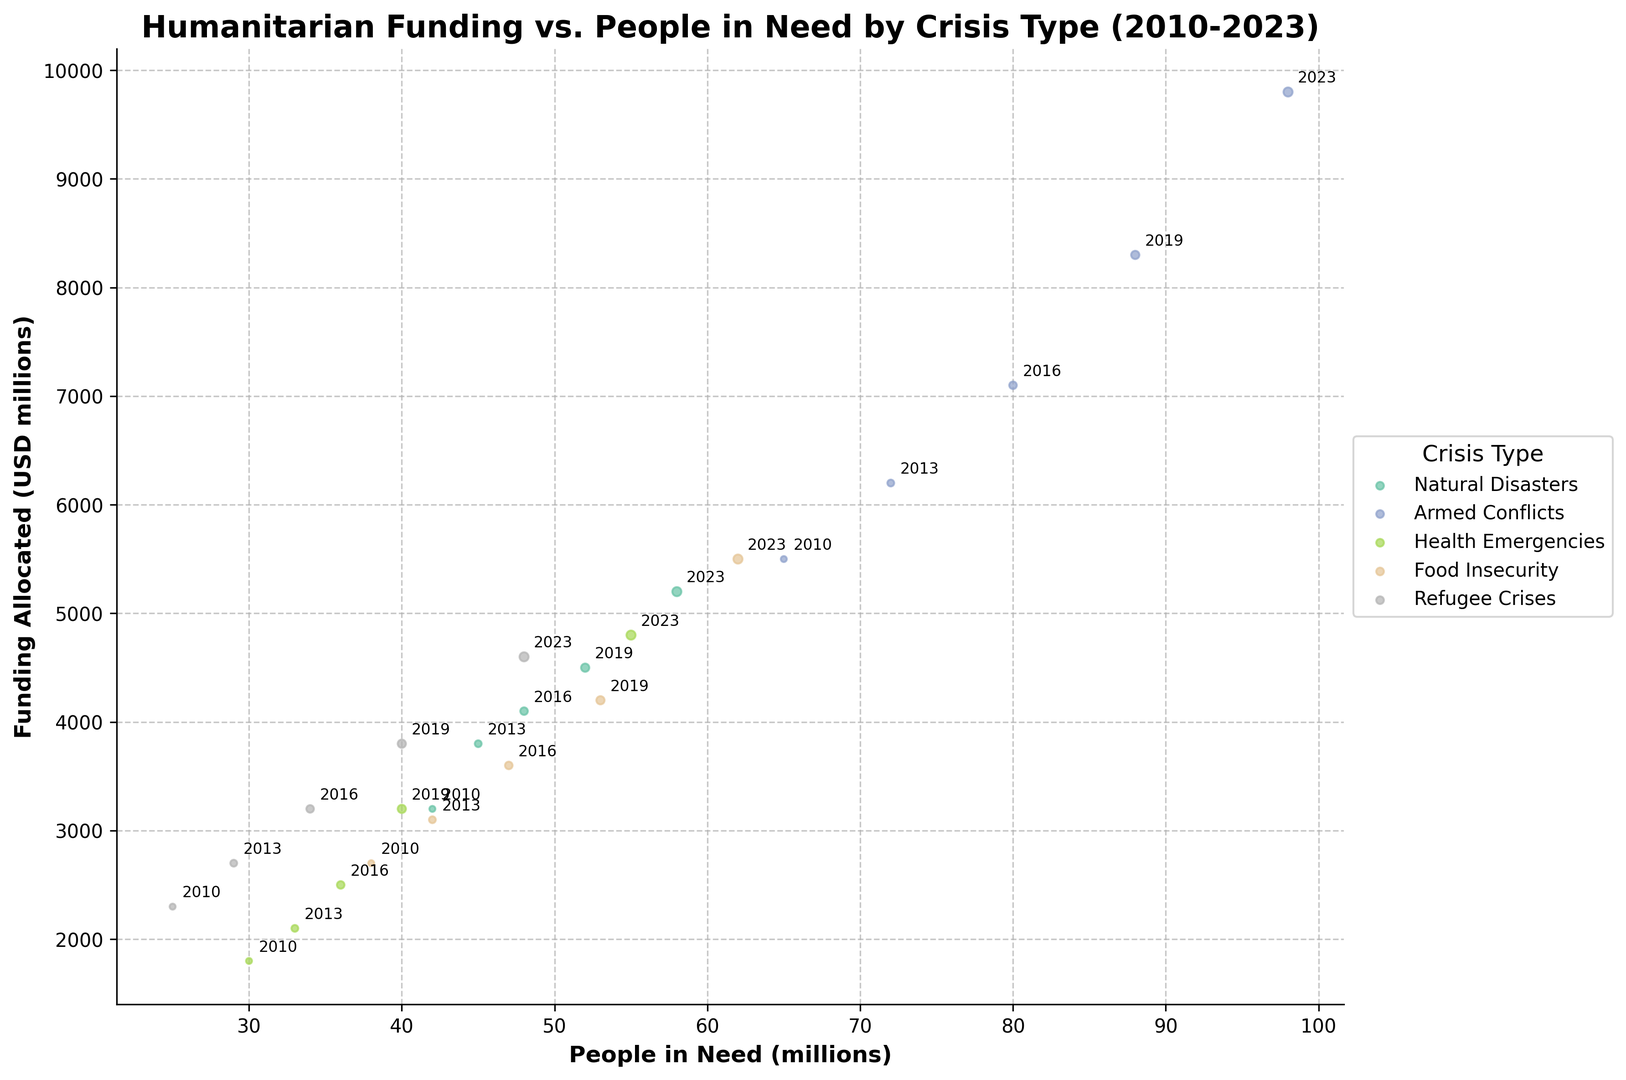Which crisis type had the highest number of people in need in 2023? Looking at the 2023 data points, the highest number of people in need is associated with Armed Conflicts.
Answer: Armed Conflicts What is the overall trend of funding allocated for Natural Disasters from 2010 to 2023? Observing the data points for Natural Disasters over the years 2010, 2013, 2016, 2019, and 2023, we can see that the funding allocated has generally increased.
Answer: Increased In which year did Food Insecurity crises see funding around 4200 million USD? Referring to the visual marks for Food Insecurity, we find the funding around 4200 million USD in the year 2019, marked by size and annotation.
Answer: 2019 How does the number of people in need in Health Emergencies in 2016 compare to that in 2023? For Health Emergencies, the 2016 data point shows 36 million people in need, while the 2023 data point shows 55 million people in need. Thus, there is an increase.
Answer: Increased Is the funding for Refugee Crises higher or lower compared to Food Insecurity in 2023? Comparing the 2023 data points, funding for Food Insecurity (5500 million USD) is higher than for Refugee Crises (4600 million USD).
Answer: Lower What's the difference in people in need between the highest and lowest crisis types in 2023? In 2023, Armed Conflicts had the highest number of people in need (98 million), and Refugee Crises had the lowest (48 million). The difference is 98 - 48 = 50 million.
Answer: 50 million Which crisis type witnessed the most significant increase in funding from 2010 to 2023? By examining the data from 2010 to 2023 for each crisis type, Armed Conflicts saw funding rise from 5500 million USD to 9800 million USD, which is the largest increase (9800 - 5500 = 4300 million USD).
Answer: Armed Conflicts Which crisis type had the smallest bubble size in 2010? Bubble sizes represent the years. The smallest bubble size (representing 2010) and the smallest value is seen with Health Emergencies.
Answer: Health Emergencies How many more people were in need due to Armed Conflicts compared to Natural Disasters in 2023? In 2023, Armed Conflicts had 98 million people in need, while Natural Disasters had 58 million. The difference is 98 - 58 = 40 million.
Answer: 40 million What is the average funding allocated across all crisis types in 2013? The 2013 funding amounts for all crisis types are: 3800 (Natural Disasters), 6200 (Armed Conflicts), 2100 (Health Emergencies), 3100 (Food Insecurity), and 2700 (Refugee Crises). The average is (3800 + 6200 + 2100 + 3100 + 2700) / 5 = 3580 million USD.
Answer: 3580 million USD 